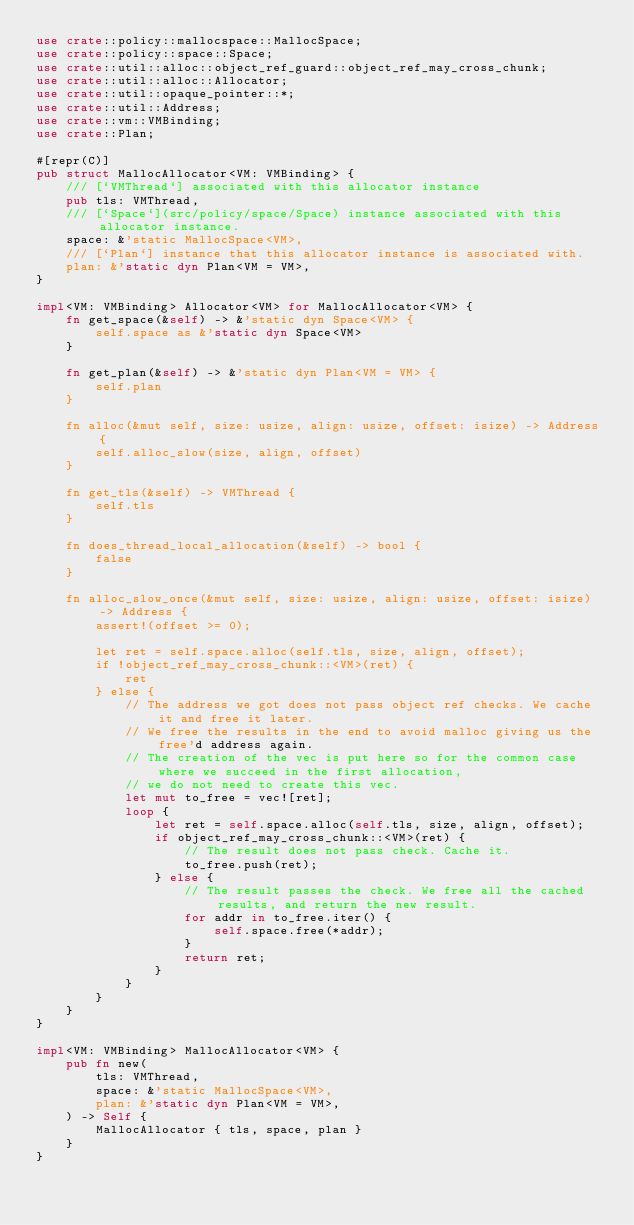<code> <loc_0><loc_0><loc_500><loc_500><_Rust_>use crate::policy::mallocspace::MallocSpace;
use crate::policy::space::Space;
use crate::util::alloc::object_ref_guard::object_ref_may_cross_chunk;
use crate::util::alloc::Allocator;
use crate::util::opaque_pointer::*;
use crate::util::Address;
use crate::vm::VMBinding;
use crate::Plan;

#[repr(C)]
pub struct MallocAllocator<VM: VMBinding> {
    /// [`VMThread`] associated with this allocator instance
    pub tls: VMThread,
    /// [`Space`](src/policy/space/Space) instance associated with this allocator instance.
    space: &'static MallocSpace<VM>,
    /// [`Plan`] instance that this allocator instance is associated with.
    plan: &'static dyn Plan<VM = VM>,
}

impl<VM: VMBinding> Allocator<VM> for MallocAllocator<VM> {
    fn get_space(&self) -> &'static dyn Space<VM> {
        self.space as &'static dyn Space<VM>
    }

    fn get_plan(&self) -> &'static dyn Plan<VM = VM> {
        self.plan
    }

    fn alloc(&mut self, size: usize, align: usize, offset: isize) -> Address {
        self.alloc_slow(size, align, offset)
    }

    fn get_tls(&self) -> VMThread {
        self.tls
    }

    fn does_thread_local_allocation(&self) -> bool {
        false
    }

    fn alloc_slow_once(&mut self, size: usize, align: usize, offset: isize) -> Address {
        assert!(offset >= 0);

        let ret = self.space.alloc(self.tls, size, align, offset);
        if !object_ref_may_cross_chunk::<VM>(ret) {
            ret
        } else {
            // The address we got does not pass object ref checks. We cache it and free it later.
            // We free the results in the end to avoid malloc giving us the free'd address again.
            // The creation of the vec is put here so for the common case where we succeed in the first allocation,
            // we do not need to create this vec.
            let mut to_free = vec![ret];
            loop {
                let ret = self.space.alloc(self.tls, size, align, offset);
                if object_ref_may_cross_chunk::<VM>(ret) {
                    // The result does not pass check. Cache it.
                    to_free.push(ret);
                } else {
                    // The result passes the check. We free all the cached results, and return the new result.
                    for addr in to_free.iter() {
                        self.space.free(*addr);
                    }
                    return ret;
                }
            }
        }
    }
}

impl<VM: VMBinding> MallocAllocator<VM> {
    pub fn new(
        tls: VMThread,
        space: &'static MallocSpace<VM>,
        plan: &'static dyn Plan<VM = VM>,
    ) -> Self {
        MallocAllocator { tls, space, plan }
    }
}
</code> 